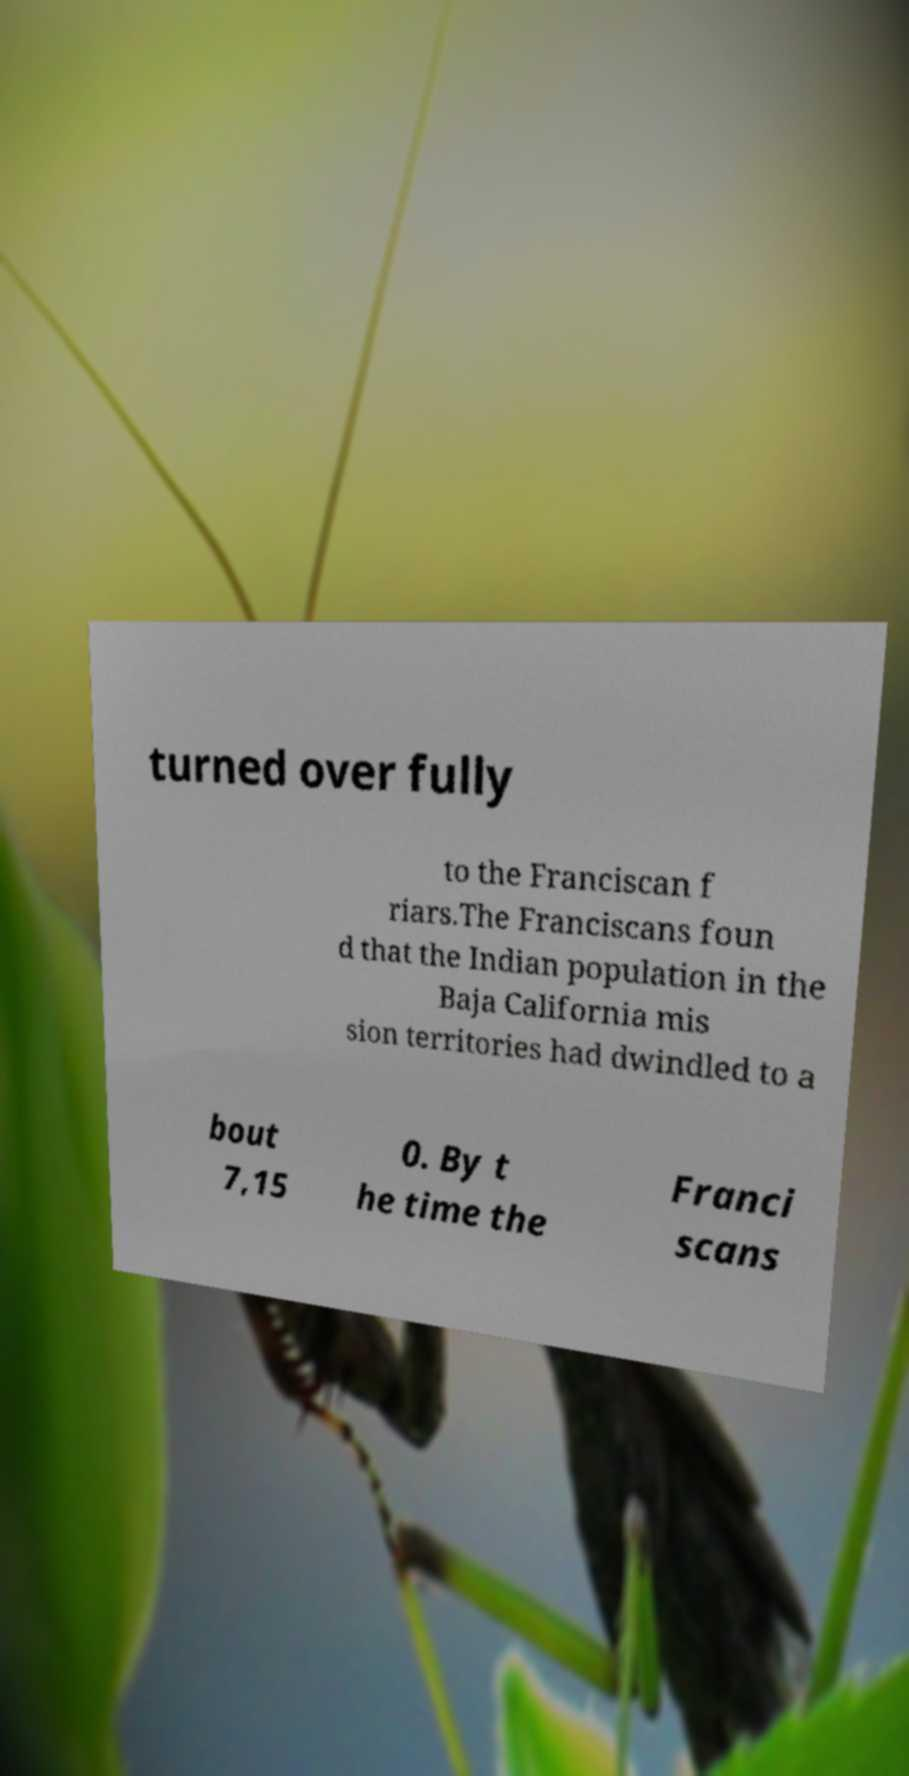Please read and relay the text visible in this image. What does it say? turned over fully to the Franciscan f riars.The Franciscans foun d that the Indian population in the Baja California mis sion territories had dwindled to a bout 7,15 0. By t he time the Franci scans 